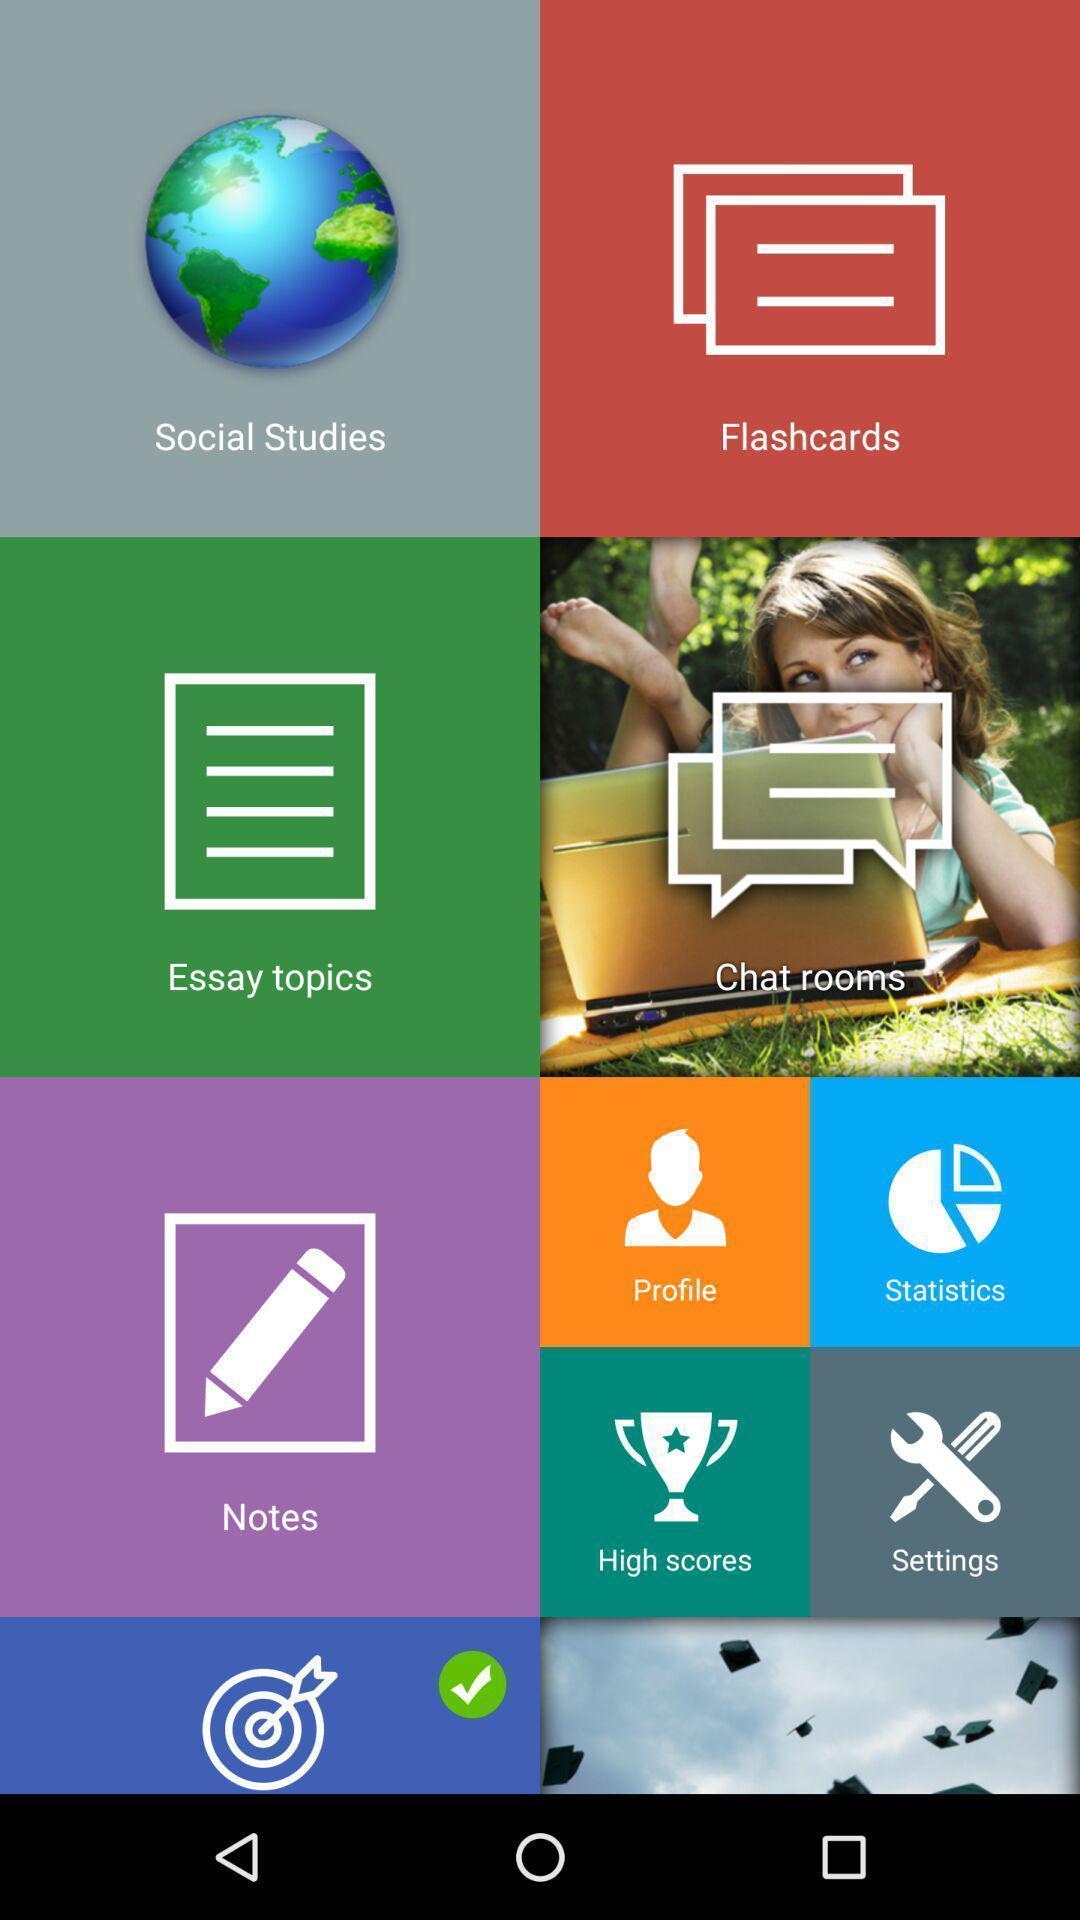Tell me what you see in this picture. Page showing sections in a general educational development. 